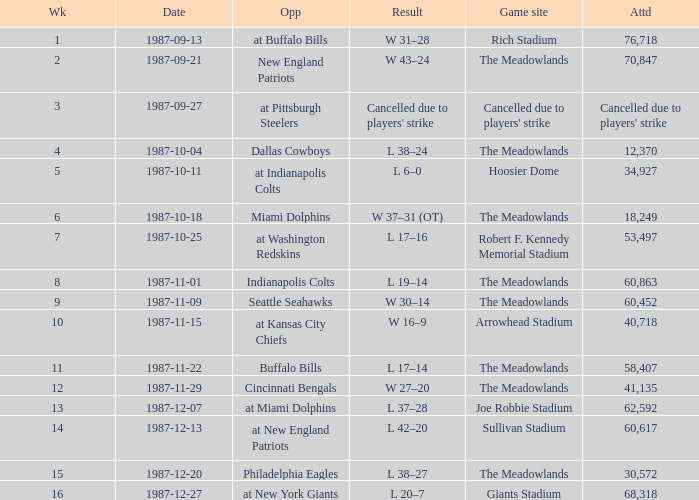Who did the Jets play in their post-week 15 game? At new york giants. 